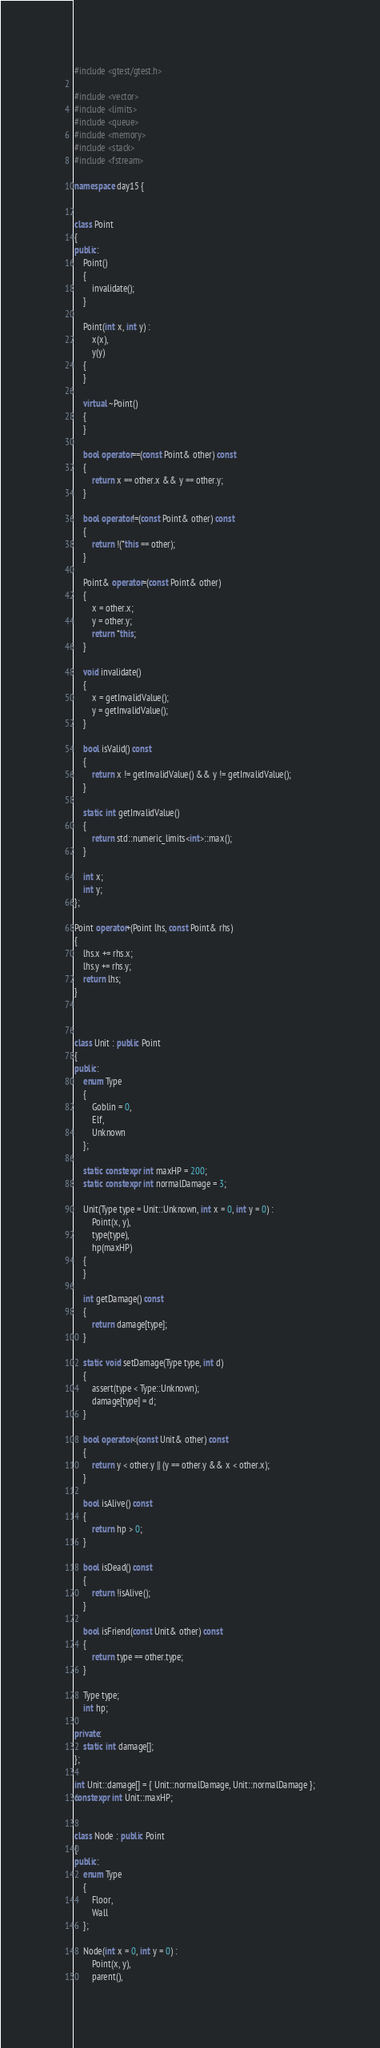Convert code to text. <code><loc_0><loc_0><loc_500><loc_500><_C++_>#include <gtest/gtest.h>

#include <vector>
#include <limits>
#include <queue>
#include <memory>
#include <stack>
#include <fstream>

namespace day15 {


class Point
{
public:
    Point()
    {
        invalidate();
    }

    Point(int x, int y) :
        x(x),
        y(y)
    {
    }

    virtual ~Point()
    {
    }

    bool operator==(const Point& other) const
    {
        return x == other.x && y == other.y;
    }

    bool operator!=(const Point& other) const
    {
        return !(*this == other);
    }

    Point& operator=(const Point& other)
    {
        x = other.x;
        y = other.y;
        return *this;
    }

    void invalidate()
    {
        x = getInvalidValue();
        y = getInvalidValue();
    }

    bool isValid() const
    {
        return x != getInvalidValue() && y != getInvalidValue();
    }

    static int getInvalidValue()
    {
        return std::numeric_limits<int>::max();
    }

    int x;
    int y;
};

Point operator+(Point lhs, const Point& rhs)
{
    lhs.x += rhs.x;
    lhs.y += rhs.y;
    return lhs;
}



class Unit : public Point
{
public:
    enum Type
    {
        Goblin = 0,
        Elf,
        Unknown
    };

    static constexpr int maxHP = 200;
    static constexpr int normalDamage = 3;

    Unit(Type type = Unit::Unknown, int x = 0, int y = 0) :
        Point(x, y),
        type(type),
        hp(maxHP)
    {
    }

    int getDamage() const
    {
        return damage[type];
    }

    static void setDamage(Type type, int d)
    {
        assert(type < Type::Unknown);
        damage[type] = d;
    }

    bool operator<(const Unit& other) const
    {
        return y < other.y || (y == other.y && x < other.x);
    }

    bool isAlive() const
    {
        return hp > 0;
    }

    bool isDead() const
    {
        return !isAlive();
    }

    bool isFriend(const Unit& other) const
    {
        return type == other.type;
    }

    Type type;
    int hp;

private:
    static int damage[];
};

int Unit::damage[] = { Unit::normalDamage, Unit::normalDamage };
constexpr int Unit::maxHP;


class Node : public Point
{
public:
    enum Type
    {
        Floor,
        Wall
    };

    Node(int x = 0, int y = 0) :
        Point(x, y),
        parent(),</code> 